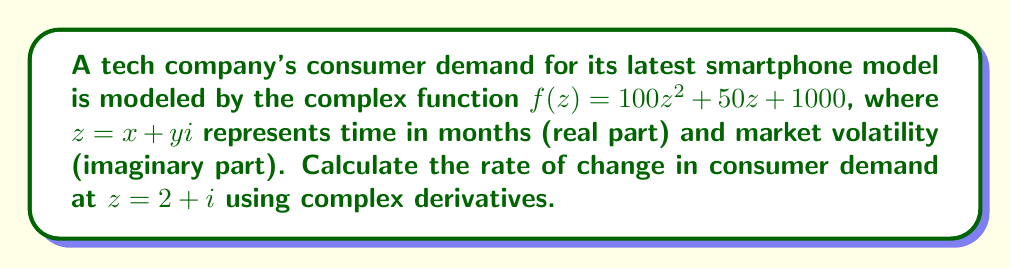Help me with this question. To solve this problem, we need to follow these steps:

1) The rate of change in consumer demand is given by the derivative of the function $f(z)$.

2) For a complex function $f(z) = u(x,y) + iv(x,y)$, the complex derivative is defined as:

   $$f'(z) = \frac{\partial u}{\partial x} + i\frac{\partial v}{\partial x}$$

   provided that the Cauchy-Riemann equations are satisfied.

3) In our case, $f(z) = 100z^2 + 50z + 1000$. Let's expand this:

   $f(z) = 100(x^2 - y^2 + 2xyi) + 50(x + yi) + 1000$
   
   $f(z) = (100x^2 - 100y^2 + 50x + 1000) + i(200xy + 50y)$

4) Now, we can identify $u(x,y)$ and $v(x,y)$:

   $u(x,y) = 100x^2 - 100y^2 + 50x + 1000$
   $v(x,y) = 200xy + 50y$

5) To find $f'(z)$, we need to calculate $\frac{\partial u}{\partial x}$:

   $\frac{\partial u}{\partial x} = 200x + 50$

6) The complex derivative is thus:

   $f'(z) = 200x + 50 + i(200y)$

7) At $z = 2 + i$, we have $x = 2$ and $y = 1$. Substituting these values:

   $f'(2 + i) = 200(2) + 50 + i(200(1))$
              $= 400 + 50 + 200i$
              $= 450 + 200i$

This complex number represents the rate of change in consumer demand at $z = 2 + i$.
Answer: The rate of change in consumer demand at $z = 2 + i$ is $450 + 200i$ units per month. 